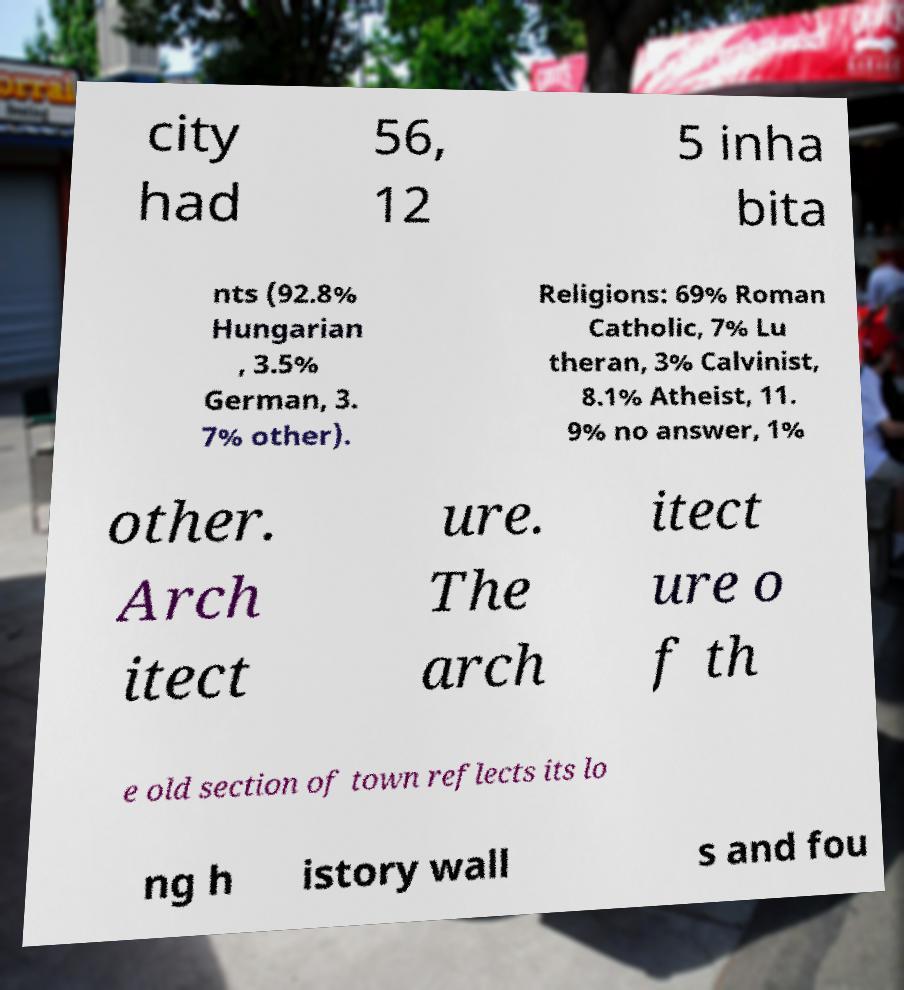Please identify and transcribe the text found in this image. city had 56, 12 5 inha bita nts (92.8% Hungarian , 3.5% German, 3. 7% other). Religions: 69% Roman Catholic, 7% Lu theran, 3% Calvinist, 8.1% Atheist, 11. 9% no answer, 1% other. Arch itect ure. The arch itect ure o f th e old section of town reflects its lo ng h istory wall s and fou 